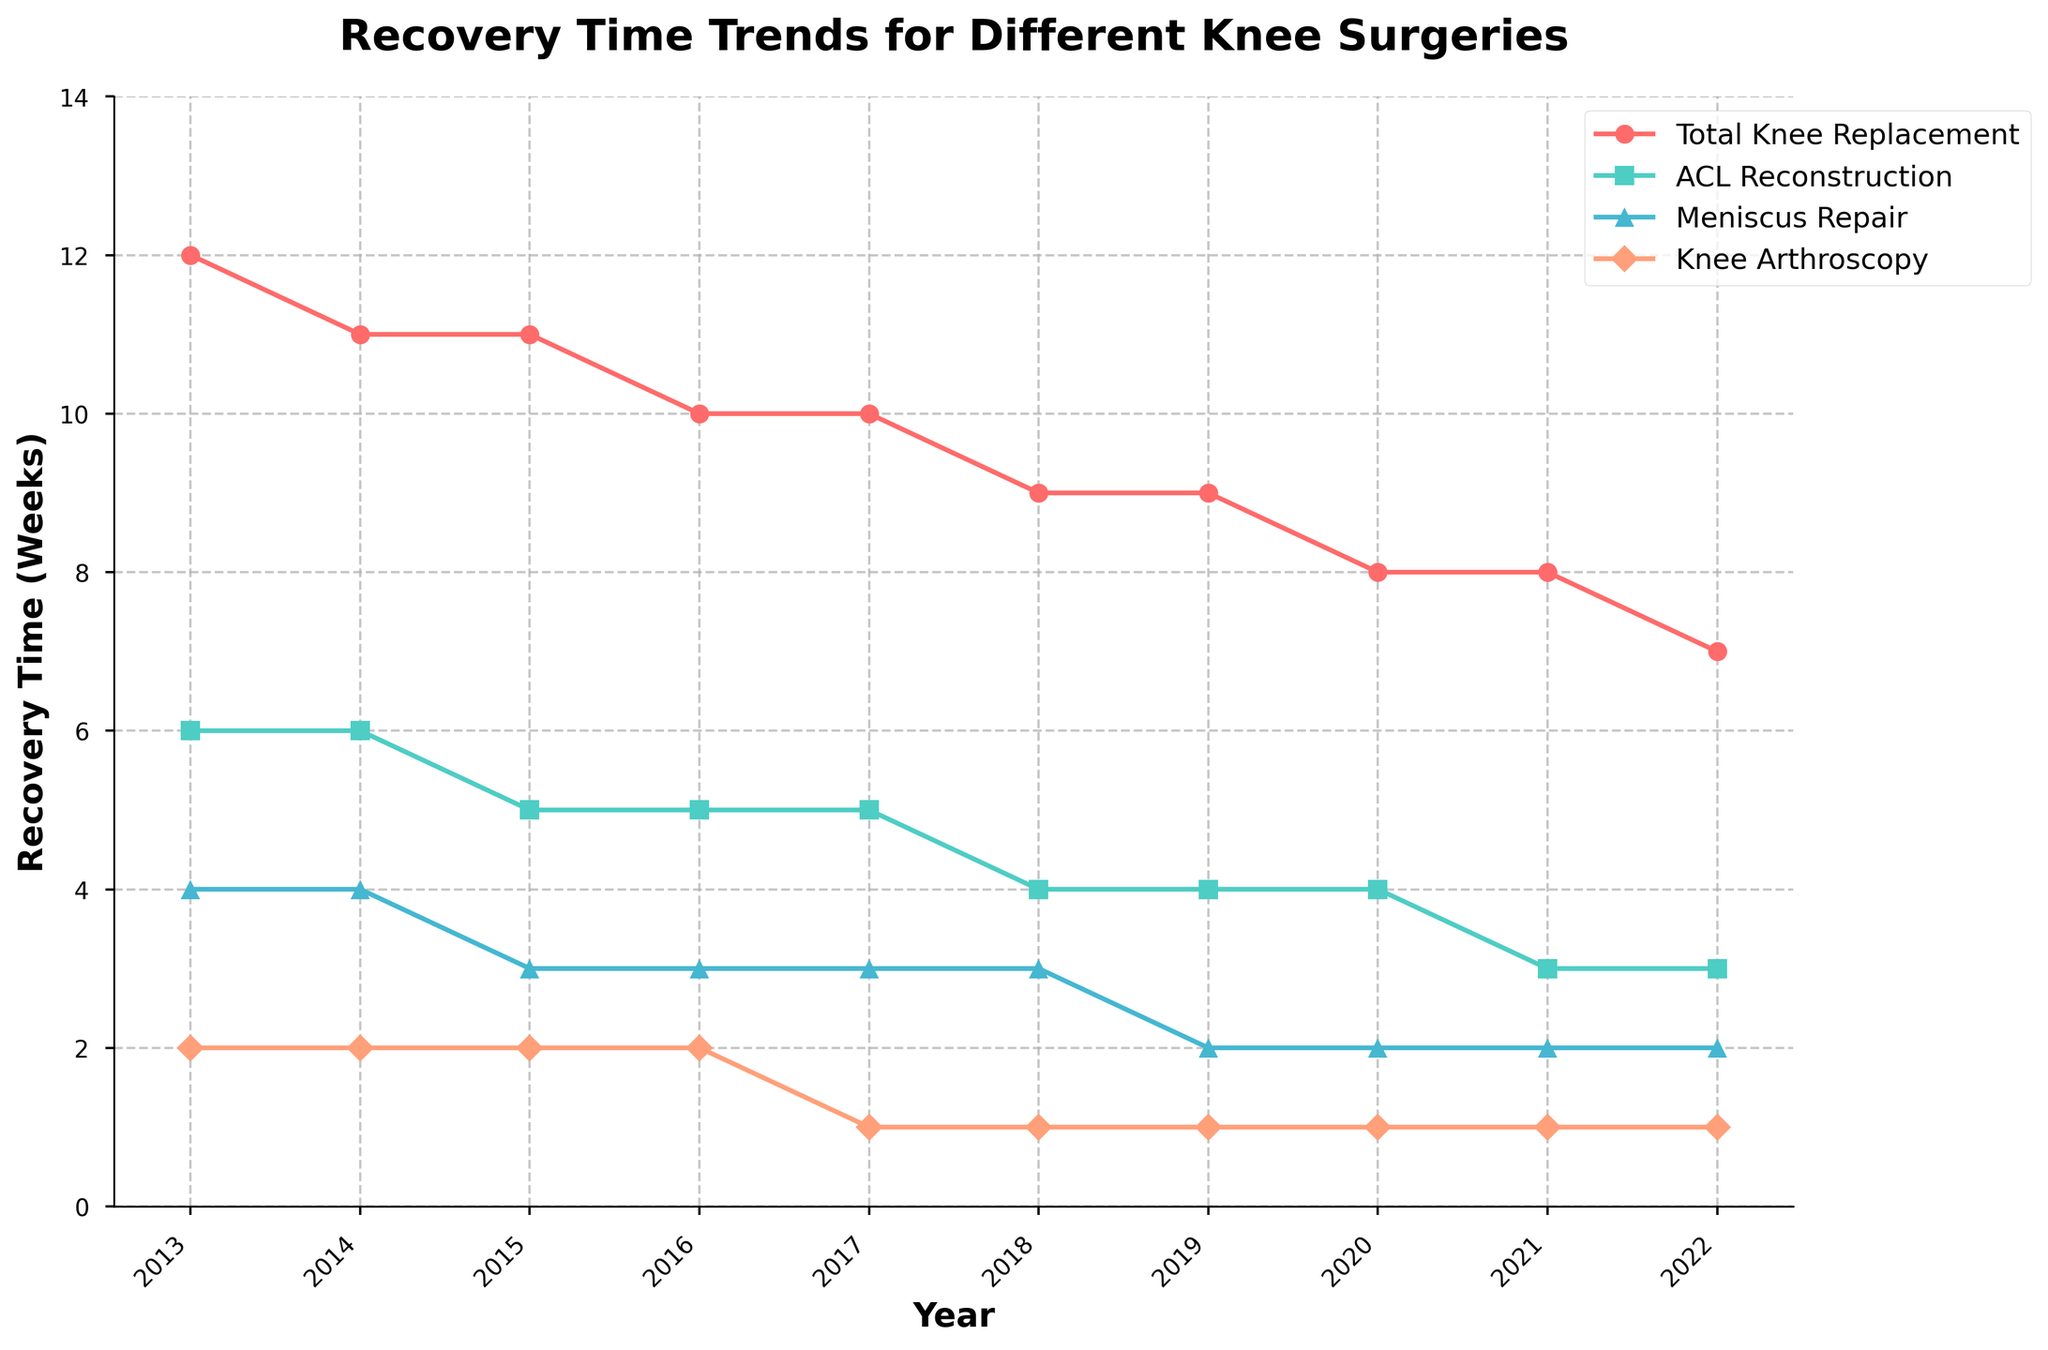What's the trend in recovery time for Total Knee Replacement from 2013 to 2022? To understand the trend, observe the line for Total Knee Replacement. It starts at 12 weeks in 2013 and consistently decreases to 7 weeks by 2022.
Answer: Decreasing In which year did ACL Reconstruction recovery time first drop to 4 weeks? By following the ACL Reconstruction line, it can be seen that it first drops to 4 weeks in 2018.
Answer: 2018 How many surgeries maintained the same recovery time from 2013 to 2022? To determine this, look at each surgery's starting and ending points. Knee Arthroscopy remains at 2 weeks, the same as in 2013.
Answer: 1 For which surgery does the recovery time decrease the most from 2013 to 2022? Compare the decrease in weeks for each surgery from 2013 to 2022. Total Knee Replacement drops from 12 to 7, ACL Reconstruction from 6 to 3, Meniscus Repair from 4 to 2, and Knee Arthroscopy from 2 to 1. Total Knee Replacement has the largest decrease of 5 weeks.
Answer: Total Knee Replacement Which surgery has the least variation in recovery time over the decade? Assess the range of values for each surgery. Knee Arthroscopy varies from 2 to 1, showing the least variation in recovery time.
Answer: Knee Arthroscopy Did any surgery's recovery time ever increase during the decade? Observe all lines for any upward movement over the years. None of the lines show any increase at any point.
Answer: No What is the average recovery time for Meniscus Repair across the decade? Sum the recovery times for Meniscus Repair over the years (4 + 4 + 3 + 3 + 3 + 3 + 2 + 2 + 2 + 2 = 28) and divide by the number of years (28/10).
Answer: 2.8 weeks In which year were the recovery times for all surgeries the lowest? Compare the recovery times for all surgeries across the years. The lowest combined recovery times are in 2022.
Answer: 2022 Is there any year when the recovery time for ACL Reconstruction and Meniscus Repair is the same? Compare the recovery time for ACL Reconstruction and Meniscus Repair in each year. In 2021 and 2022, both recoveries are at 3 and 2 weeks, respectively.
Answer: Yes, 2021 and 2022 